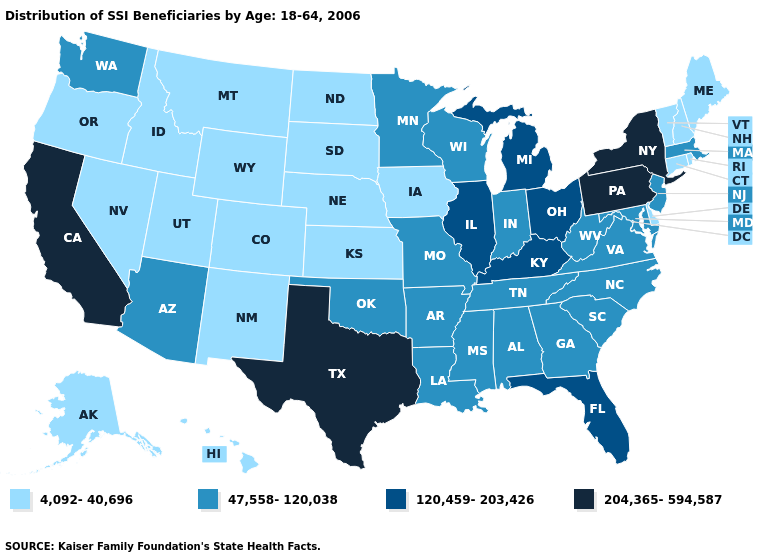Name the states that have a value in the range 204,365-594,587?
Answer briefly. California, New York, Pennsylvania, Texas. What is the value of Maryland?
Write a very short answer. 47,558-120,038. Which states have the lowest value in the USA?
Be succinct. Alaska, Colorado, Connecticut, Delaware, Hawaii, Idaho, Iowa, Kansas, Maine, Montana, Nebraska, Nevada, New Hampshire, New Mexico, North Dakota, Oregon, Rhode Island, South Dakota, Utah, Vermont, Wyoming. Name the states that have a value in the range 47,558-120,038?
Be succinct. Alabama, Arizona, Arkansas, Georgia, Indiana, Louisiana, Maryland, Massachusetts, Minnesota, Mississippi, Missouri, New Jersey, North Carolina, Oklahoma, South Carolina, Tennessee, Virginia, Washington, West Virginia, Wisconsin. Among the states that border North Dakota , which have the lowest value?
Answer briefly. Montana, South Dakota. Is the legend a continuous bar?
Quick response, please. No. What is the value of Maryland?
Be succinct. 47,558-120,038. What is the value of Texas?
Keep it brief. 204,365-594,587. What is the value of Wyoming?
Concise answer only. 4,092-40,696. Does Georgia have the lowest value in the South?
Quick response, please. No. Does Texas have the highest value in the South?
Concise answer only. Yes. Name the states that have a value in the range 4,092-40,696?
Give a very brief answer. Alaska, Colorado, Connecticut, Delaware, Hawaii, Idaho, Iowa, Kansas, Maine, Montana, Nebraska, Nevada, New Hampshire, New Mexico, North Dakota, Oregon, Rhode Island, South Dakota, Utah, Vermont, Wyoming. What is the highest value in the South ?
Give a very brief answer. 204,365-594,587. Which states have the highest value in the USA?
Keep it brief. California, New York, Pennsylvania, Texas. What is the lowest value in the West?
Quick response, please. 4,092-40,696. 